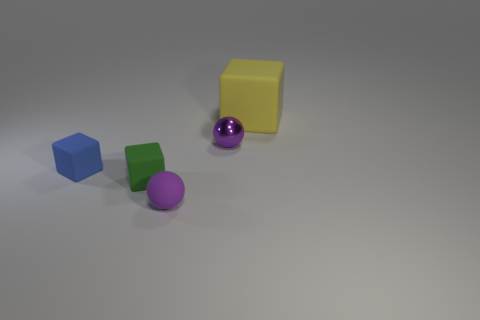What number of tiny matte objects are there?
Provide a short and direct response. 3. Does the purple thing behind the purple matte thing have the same shape as the purple rubber object?
Make the answer very short. Yes. What material is the blue thing that is the same size as the metallic ball?
Your response must be concise. Rubber. Are there any tiny purple balls that have the same material as the large yellow block?
Give a very brief answer. Yes. There is a large thing; is it the same shape as the small green matte object in front of the tiny purple metallic ball?
Keep it short and to the point. Yes. How many things are to the right of the small blue rubber cube and on the left side of the large yellow block?
Your answer should be very brief. 3. Does the large thing have the same material as the small purple ball that is behind the small purple matte object?
Make the answer very short. No. Are there the same number of purple shiny objects on the right side of the tiny matte sphere and small gray cylinders?
Keep it short and to the point. No. There is a tiny sphere in front of the tiny blue matte object; what is its color?
Your response must be concise. Purple. How many other objects are the same color as the shiny ball?
Make the answer very short. 1. 